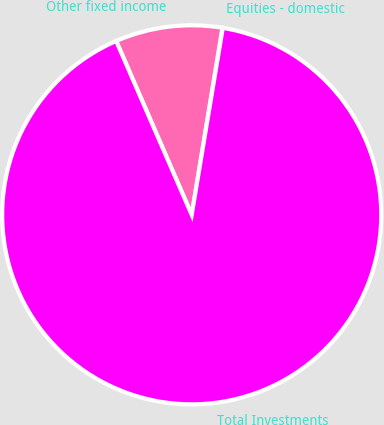<chart> <loc_0><loc_0><loc_500><loc_500><pie_chart><fcel>Equities - domestic<fcel>Other fixed income<fcel>Total Investments<nl><fcel>0.03%<fcel>9.12%<fcel>90.85%<nl></chart> 